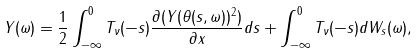<formula> <loc_0><loc_0><loc_500><loc_500>Y ( \omega ) = \frac { 1 } { 2 } \int _ { - \infty } ^ { 0 } T _ { \nu } ( - s ) \frac { \partial ( Y ( \theta ( s , \omega ) ) ^ { 2 } ) } { \partial x } d s + \int _ { - \infty } ^ { 0 } T _ { \nu } ( - s ) d W _ { s } ( \omega ) ,</formula> 